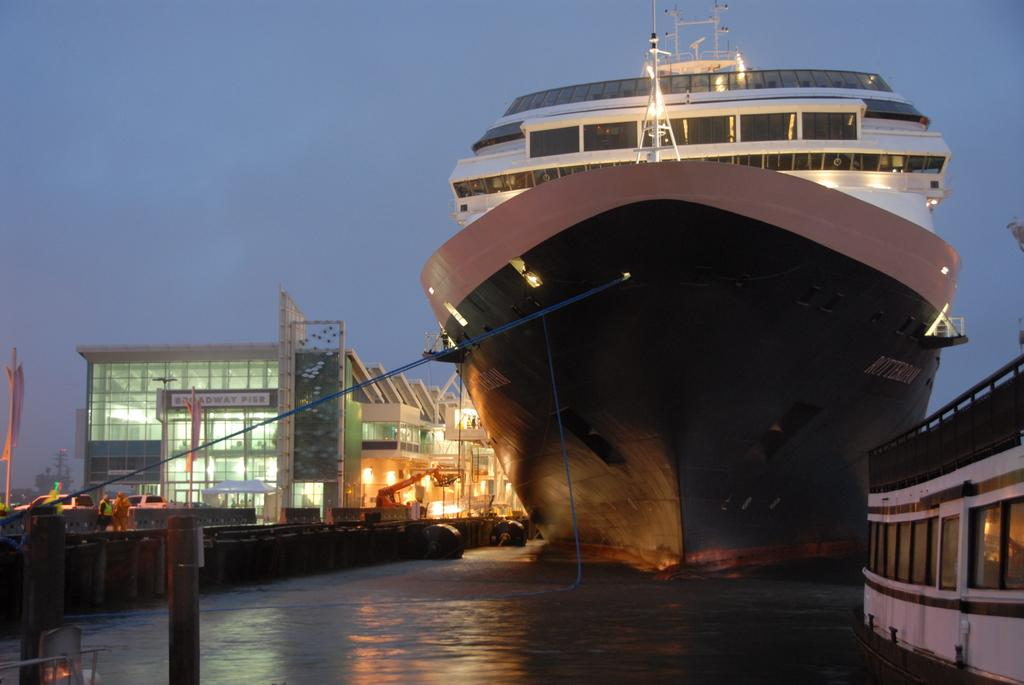Provide a one-sentence caption for the provided image. A huge ship that has a sign to the left that says Broadway Pier on it. 